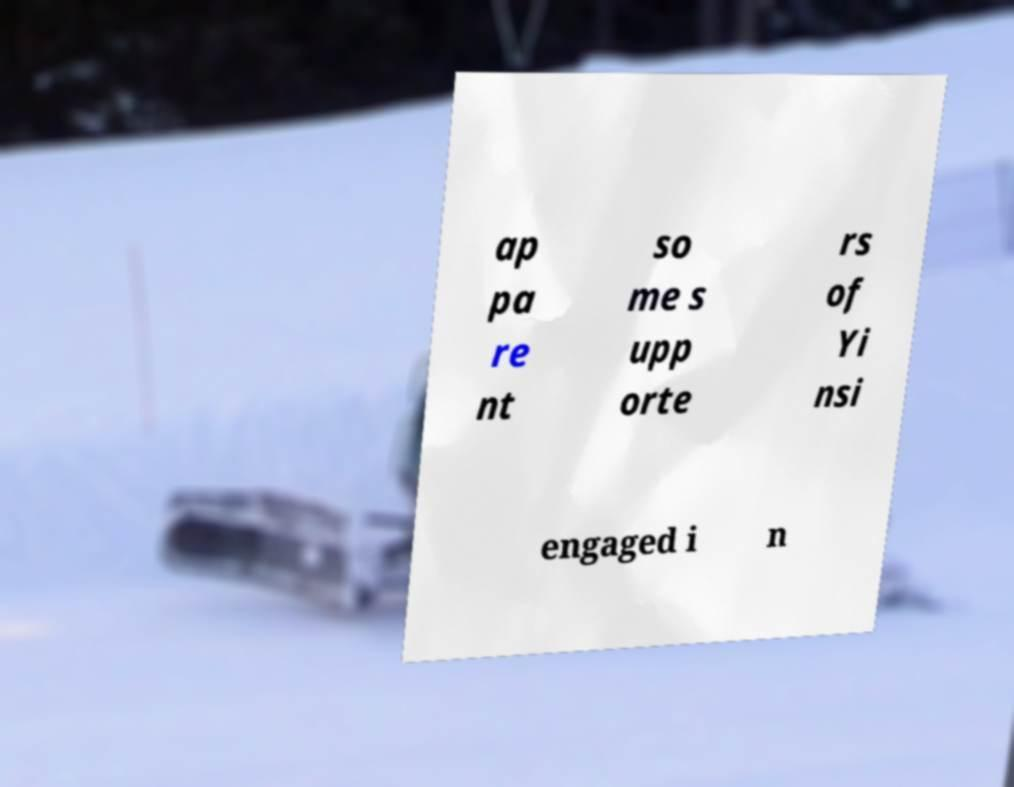I need the written content from this picture converted into text. Can you do that? ap pa re nt so me s upp orte rs of Yi nsi engaged i n 